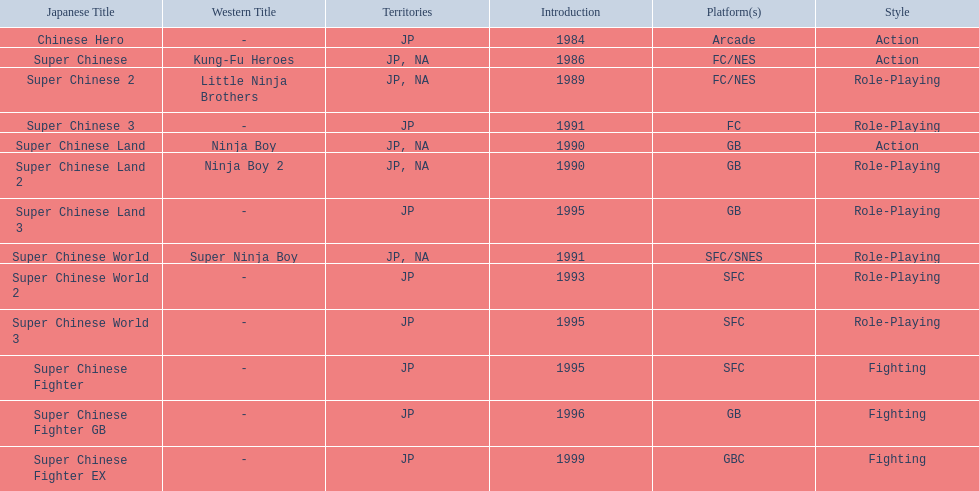When was the last super chinese game released? 1999. 